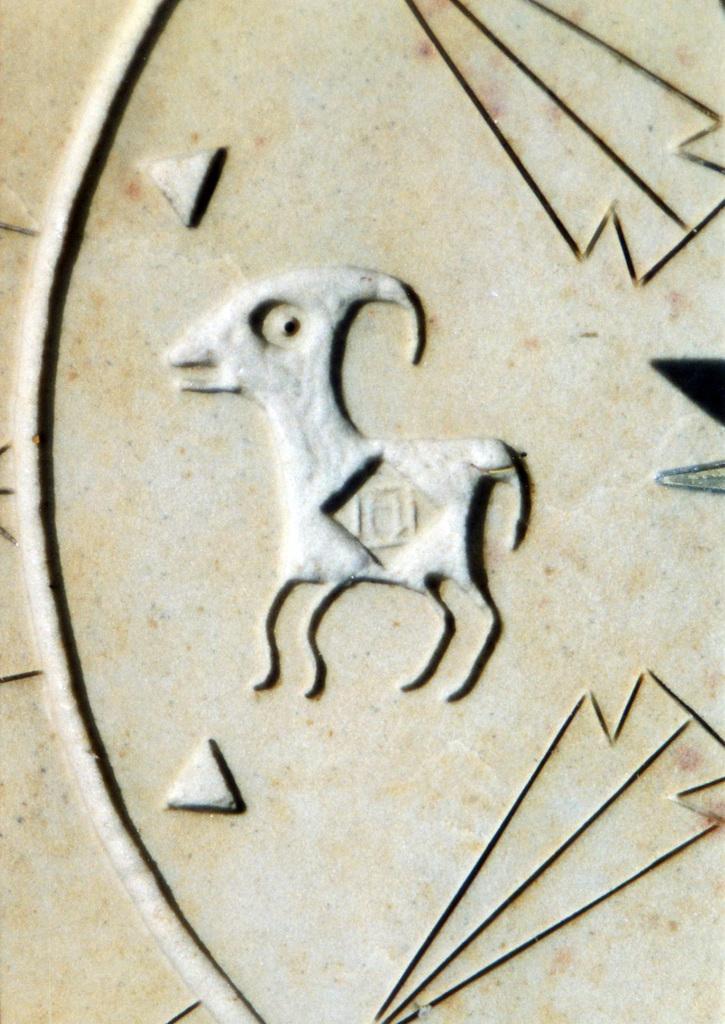Please provide a concise description of this image. In this image I can see some art design on a surface. 